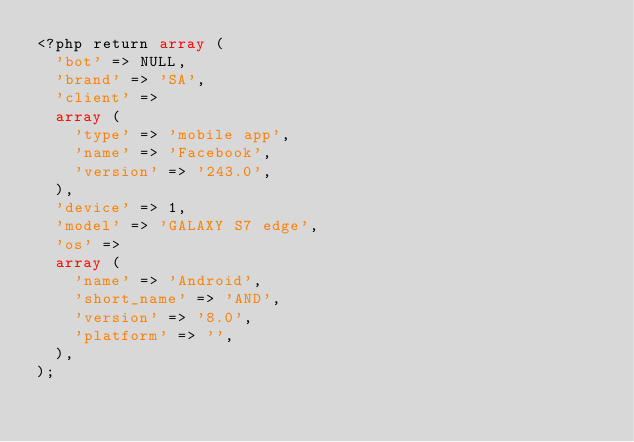<code> <loc_0><loc_0><loc_500><loc_500><_PHP_><?php return array (
  'bot' => NULL,
  'brand' => 'SA',
  'client' => 
  array (
    'type' => 'mobile app',
    'name' => 'Facebook',
    'version' => '243.0',
  ),
  'device' => 1,
  'model' => 'GALAXY S7 edge',
  'os' => 
  array (
    'name' => 'Android',
    'short_name' => 'AND',
    'version' => '8.0',
    'platform' => '',
  ),
);</code> 